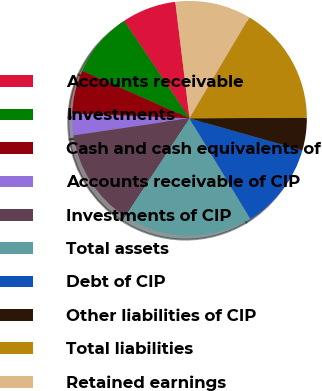Convert chart to OTSL. <chart><loc_0><loc_0><loc_500><loc_500><pie_chart><fcel>Accounts receivable<fcel>Investments<fcel>Cash and cash equivalents of<fcel>Accounts receivable of CIP<fcel>Investments of CIP<fcel>Total assets<fcel>Debt of CIP<fcel>Other liabilities of CIP<fcel>Total liabilities<fcel>Retained earnings<nl><fcel>7.47%<fcel>8.96%<fcel>5.98%<fcel>2.99%<fcel>13.43%<fcel>17.9%<fcel>11.94%<fcel>4.48%<fcel>16.41%<fcel>10.45%<nl></chart> 